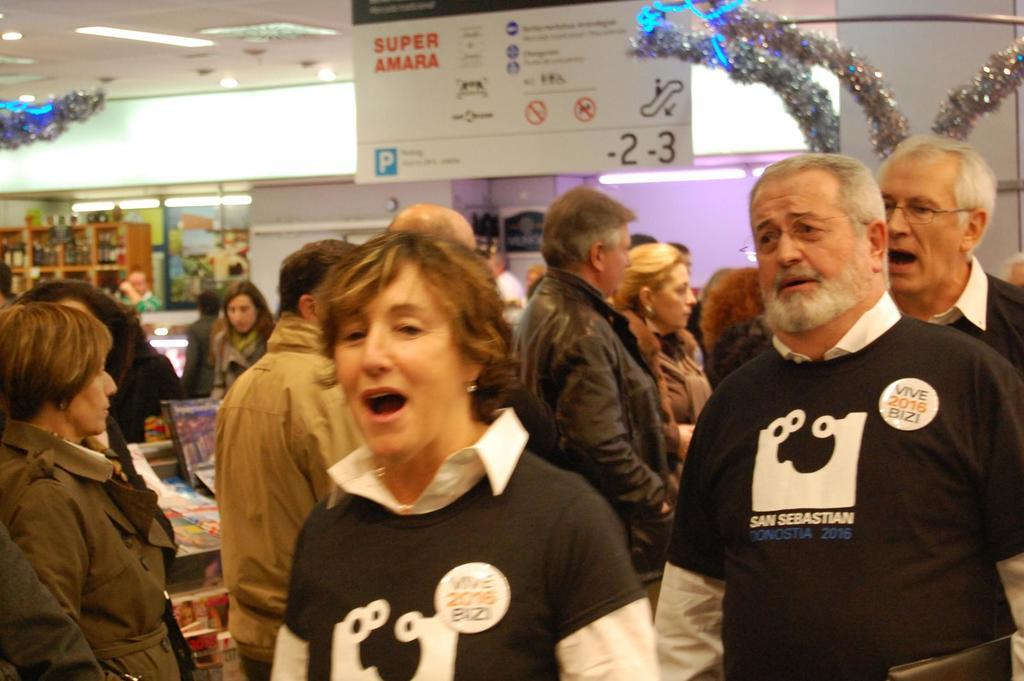Who or what is present in the image? There are people in the image. What can be seen at the top of the image? Decorative items are visible at the top of the image. What type of lighting is present in the image? Ceiling lights are present in the image. What is on a platform in the image? There are objects on a platform in the image. What is visible in the background of the image? There is a wall and lights in the background of the image, as well as objects in racks. What type of watch is being traded by the people in the image? There is no watch or trading activity present in the image. How many legs can be seen on the people in the image? The image does not show the legs of the people, so it cannot be determined from the image. 